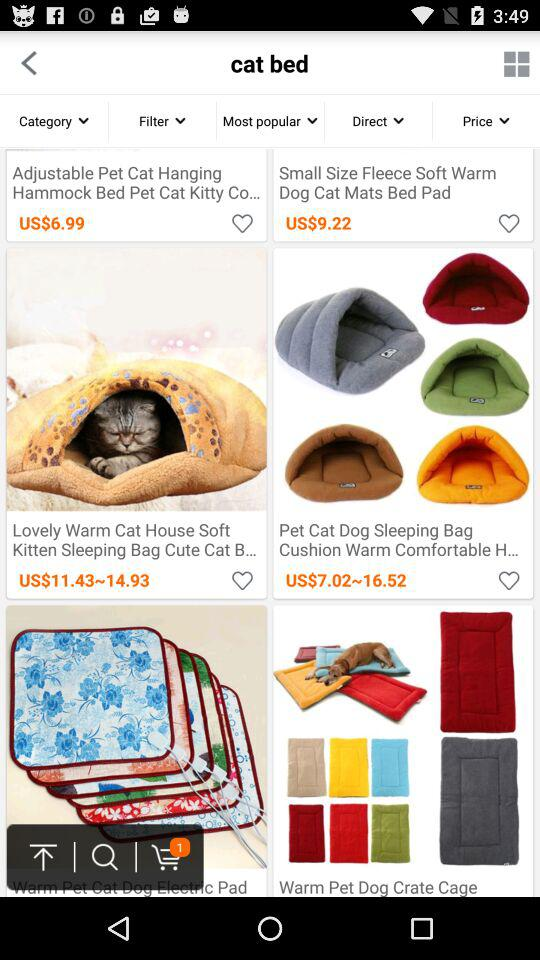What is the price range for the "Lovely Warm Cat House Soft Kitten Sleeping Bag Cute Cat B..."? The price range is from US$11.43 to $14.93. 